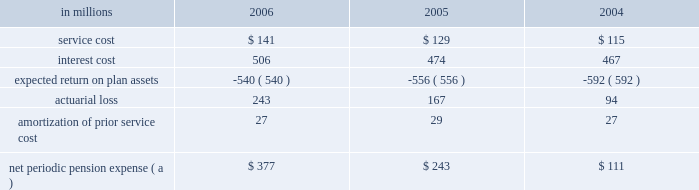Institutions .
International paper continually monitors its positions with and the credit quality of these financial institutions and does not expect non- performance by the counterparties .
Note 14 capital stock the authorized capital stock at both december 31 , 2006 and 2005 , consisted of 990850000 shares of common stock , $ 1 par value ; 400000 shares of cumulative $ 4 preferred stock , without par value ( stated value $ 100 per share ) ; and 8750000 shares of serial preferred stock , $ 1 par value .
The serial preferred stock is issuable in one or more series by the board of directors without further shareholder action .
In july 2006 , in connection with the planned use of projected proceeds from the company 2019s trans- formation plan , international paper 2019s board of direc- tors authorized a share repurchase program to acquire up to $ 3.0 billion of the company 2019s stock .
In a modified 201cdutch auction 201d tender offer completed in september 2006 , international paper purchased 38465260 shares of its common stock at a price of $ 36.00 per share , plus costs to acquire the shares , for a total cost of approximately $ 1.4 billion .
In addition , in december 2006 , the company purchased an addi- tional 1220558 shares of its common stock in the open market at an average price of $ 33.84 per share , plus costs to acquire the shares , for a total cost of approximately $ 41 million .
Following the completion of these share repurchases , international paper had approximately 454 million shares of common stock issued and outstanding .
Note 15 retirement plans u.s .
Defined benefit plans international paper maintains pension plans that provide retirement benefits to substantially all domestic employees hired prior to july 1 , 2004 .
These employees generally are eligible to participate in the plans upon completion of one year of service and attainment of age 21 .
Employees hired after june 30 , 2004 , who are not eligible for these pension plans receive an additional company contribution to their savings plan ( see 201cother plans 201d on page 83 ) .
The plans provide defined benefits based on years of credited service and either final average earnings ( salaried employees ) , hourly job rates or specified benefit rates ( hourly and union employees ) .
For its qualified defined benefit pension plan , interna- tional paper makes contributions that are sufficient to fully fund its actuarially determined costs , gen- erally equal to the minimum amounts required by the employee retirement income security act ( erisa ) .
In addition , international paper made volun- tary contributions of $ 1.0 billion to the qualified defined benefit plan in 2006 , and does not expect to make any contributions in 2007 .
The company also has two unfunded nonqualified defined benefit pension plans : a pension restoration plan available to employees hired prior to july 1 , 2004 that provides retirement benefits based on eligible compensation in excess of limits set by the internal revenue service , and a supplemental retirement plan for senior managers ( serp ) , which is an alternative retirement plan for senior vice presi- dents and above who are designated by the chief executive officer as participants .
These nonqualified plans are only funded to the extent of benefits paid , which are expected to be $ 41 million in 2007 .
Net periodic pension expense service cost is the actuarial present value of benefits attributed by the plans 2019 benefit formula to services rendered by employees during the year .
Interest cost represents the increase in the projected benefit obli- gation , which is a discounted amount , due to the passage of time .
The expected return on plan assets reflects the computed amount of current year earn- ings from the investment of plan assets using an estimated long-term rate of return .
Net periodic pension expense for qualified and nonqualified u.s .
Defined benefit plans comprised the following : in millions 2006 2005 2004 .
( a ) excludes $ 9.1 million , $ 6.5 million and $ 3.4 million in 2006 , 2005 and 2004 , respectively , in curtailment losses , and $ 8.7 million , $ 3.6 million and $ 1.4 million in 2006 , 2005 and 2004 , respectively , of termination benefits , in connection with cost reduction programs and facility rationalizations that were recorded in restructuring and other charges in the con- solidated statement of operations .
Also excludes $ 77.2 million and $ 14.3 million in 2006 and 2005 , respectively , in curtailment losses , and $ 18.6 million and $ 7.6 million of termination bene- fits in 2006 and 2005 , respectively , related to certain divest- itures recorded in net losses on sales and impairments of businesses held for sale in the consolidated statement of oper- ations. .
What is the percentage change in net periodic pension expense between 2004 and 2005? 
Computations: ((243 - 111) / 111)
Answer: 1.18919. 